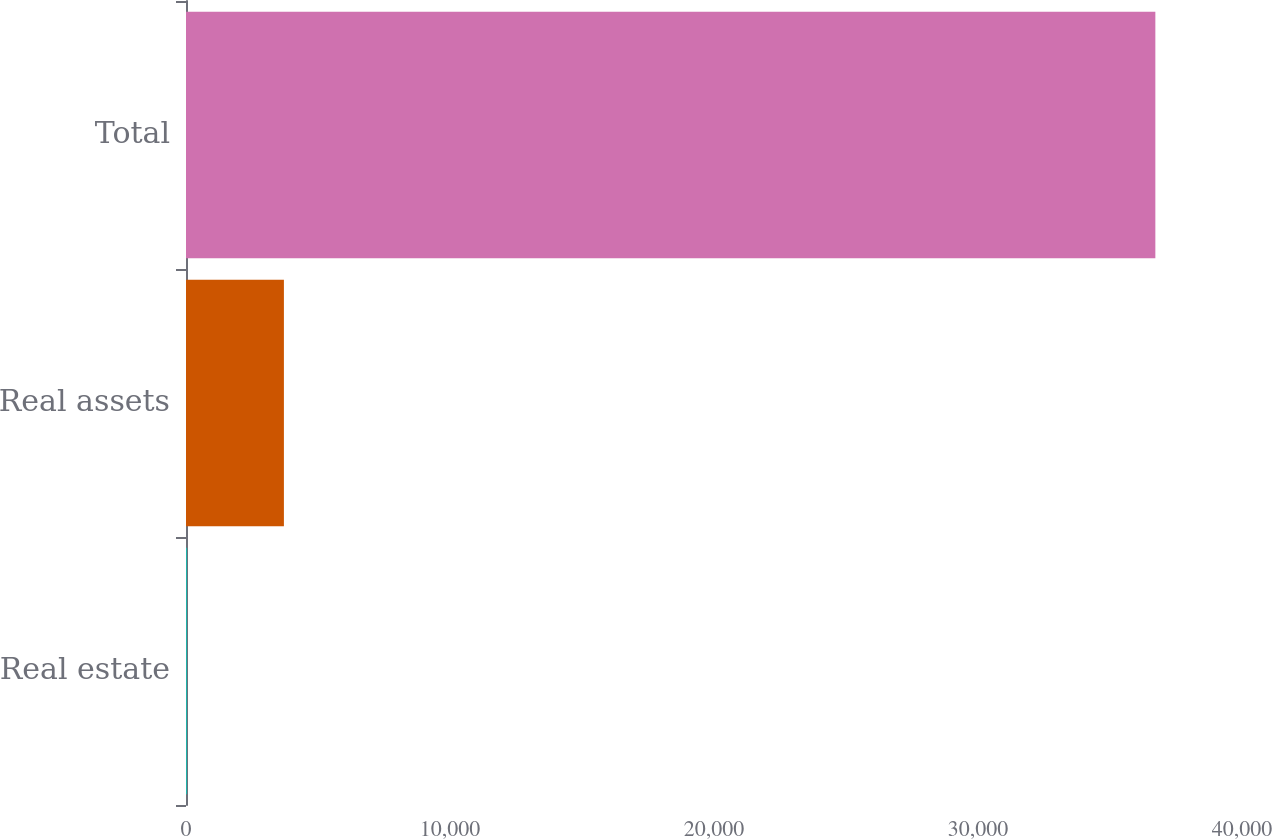Convert chart to OTSL. <chart><loc_0><loc_0><loc_500><loc_500><bar_chart><fcel>Real estate<fcel>Real assets<fcel>Total<nl><fcel>41<fcel>3708.7<fcel>36718<nl></chart> 